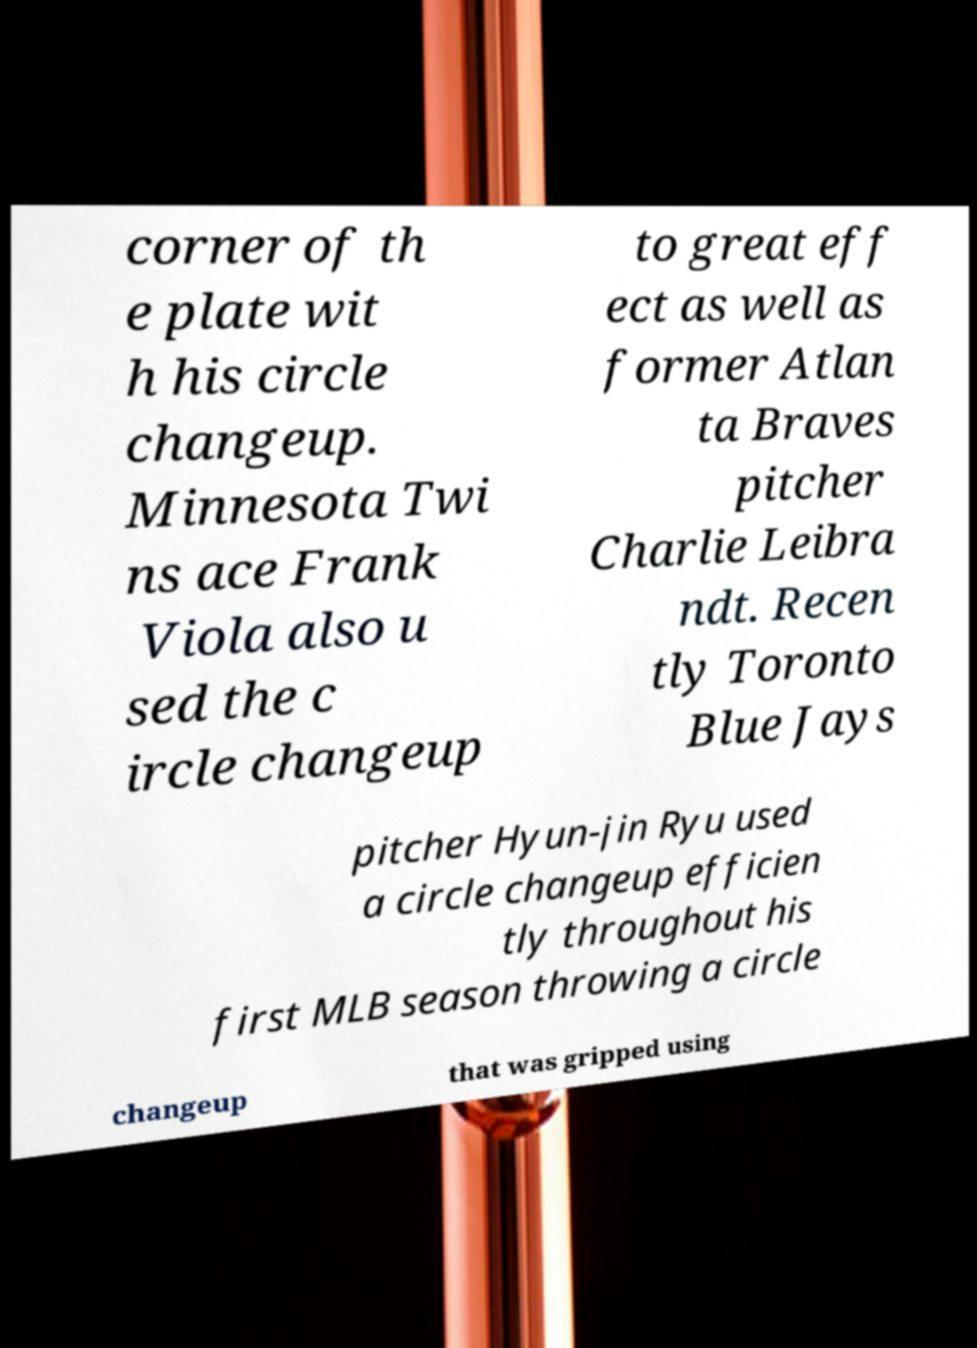What messages or text are displayed in this image? I need them in a readable, typed format. corner of th e plate wit h his circle changeup. Minnesota Twi ns ace Frank Viola also u sed the c ircle changeup to great eff ect as well as former Atlan ta Braves pitcher Charlie Leibra ndt. Recen tly Toronto Blue Jays pitcher Hyun-jin Ryu used a circle changeup efficien tly throughout his first MLB season throwing a circle changeup that was gripped using 